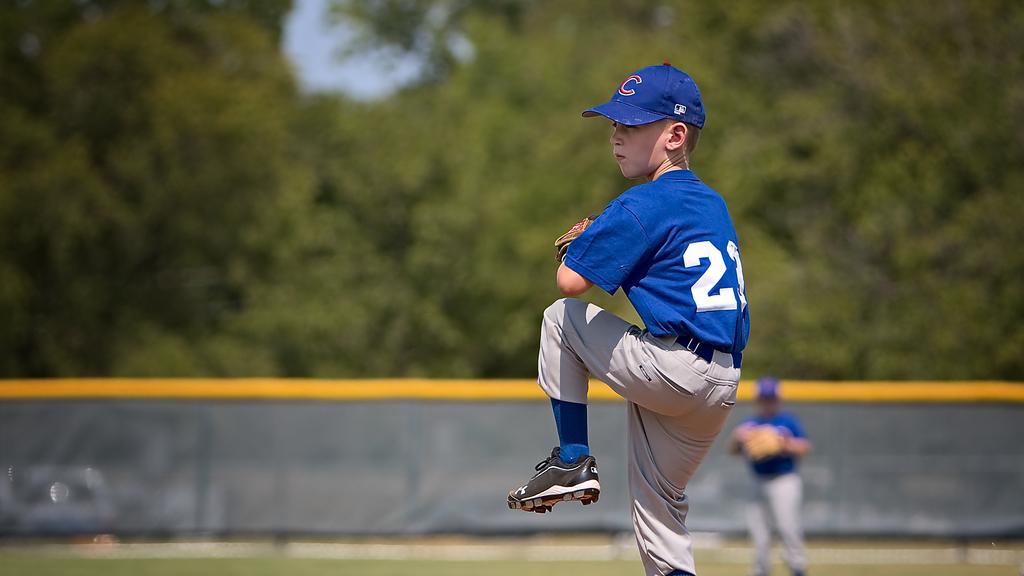What letter is on his cap?
Make the answer very short. C. 